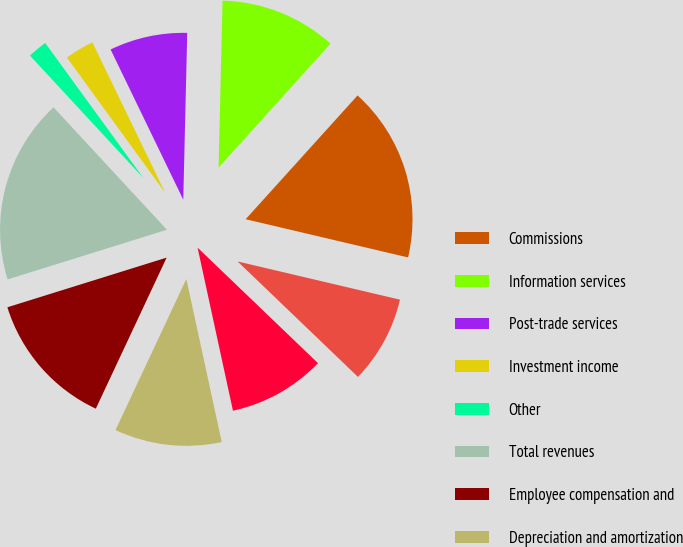<chart> <loc_0><loc_0><loc_500><loc_500><pie_chart><fcel>Commissions<fcel>Information services<fcel>Post-trade services<fcel>Investment income<fcel>Other<fcel>Total revenues<fcel>Employee compensation and<fcel>Depreciation and amortization<fcel>Technology and communications<fcel>Professional and consulting<nl><fcel>16.98%<fcel>11.32%<fcel>7.55%<fcel>2.83%<fcel>1.89%<fcel>17.92%<fcel>13.21%<fcel>10.38%<fcel>9.43%<fcel>8.49%<nl></chart> 